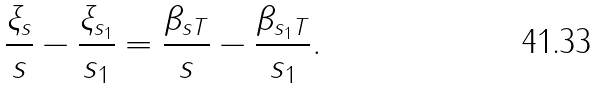<formula> <loc_0><loc_0><loc_500><loc_500>\frac { \xi _ { s } } { s } - \frac { \xi _ { s _ { 1 } } } { s _ { 1 } } = \frac { \beta _ { s T } } { s } - \frac { \beta _ { s _ { 1 } T } } { s _ { 1 } } .</formula> 